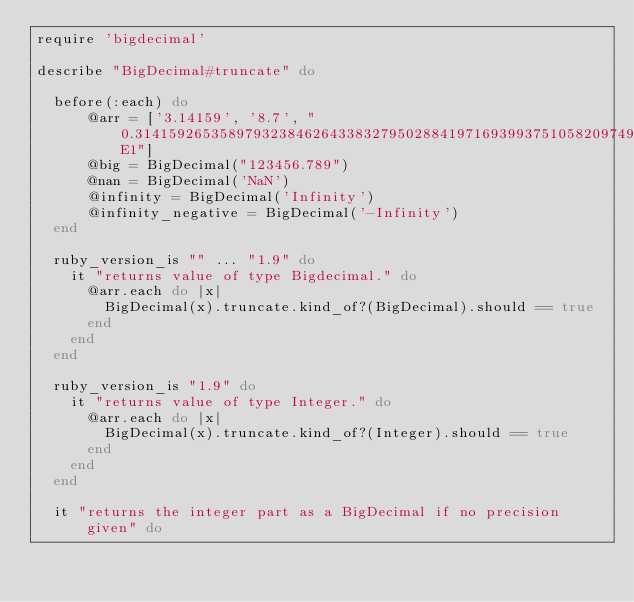<code> <loc_0><loc_0><loc_500><loc_500><_Ruby_>require 'bigdecimal'

describe "BigDecimal#truncate" do

  before(:each) do
      @arr = ['3.14159', '8.7', "0.314159265358979323846264338327950288419716939937510582097494459230781640628620899862803482534211706798214808651328230664709384460955058223172535940812848111745028410270193852110555964462294895493038196442881097566593014782083152134043E1"]
      @big = BigDecimal("123456.789")
      @nan = BigDecimal('NaN')
      @infinity = BigDecimal('Infinity')
      @infinity_negative = BigDecimal('-Infinity')
  end

  ruby_version_is "" ... "1.9" do
    it "returns value of type Bigdecimal." do
      @arr.each do |x|
        BigDecimal(x).truncate.kind_of?(BigDecimal).should == true
      end
    end
  end

  ruby_version_is "1.9" do
    it "returns value of type Integer." do
      @arr.each do |x|
        BigDecimal(x).truncate.kind_of?(Integer).should == true
      end
    end
  end

  it "returns the integer part as a BigDecimal if no precision given" do</code> 